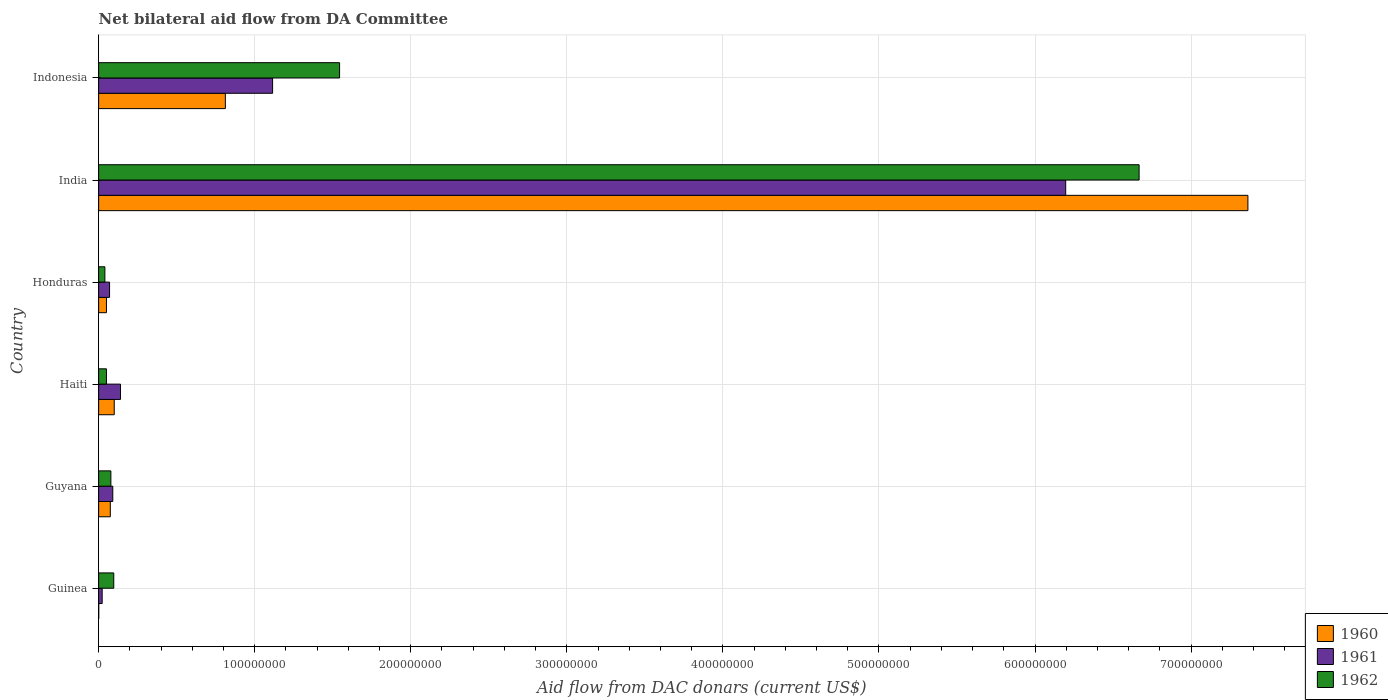How many different coloured bars are there?
Provide a short and direct response. 3. Are the number of bars on each tick of the Y-axis equal?
Your answer should be compact. Yes. How many bars are there on the 3rd tick from the bottom?
Your response must be concise. 3. What is the label of the 4th group of bars from the top?
Give a very brief answer. Haiti. Across all countries, what is the maximum aid flow in in 1962?
Provide a succinct answer. 6.67e+08. Across all countries, what is the minimum aid flow in in 1962?
Your answer should be compact. 4.00e+06. In which country was the aid flow in in 1962 maximum?
Offer a terse response. India. In which country was the aid flow in in 1961 minimum?
Ensure brevity in your answer.  Guinea. What is the total aid flow in in 1960 in the graph?
Your answer should be very brief. 8.40e+08. What is the difference between the aid flow in in 1961 in Guyana and that in Honduras?
Give a very brief answer. 2.07e+06. What is the difference between the aid flow in in 1960 in Indonesia and the aid flow in in 1962 in Guinea?
Offer a terse response. 7.15e+07. What is the average aid flow in in 1960 per country?
Provide a short and direct response. 1.40e+08. What is the difference between the aid flow in in 1960 and aid flow in in 1962 in India?
Provide a short and direct response. 6.97e+07. In how many countries, is the aid flow in in 1960 greater than 600000000 US$?
Offer a terse response. 1. What is the ratio of the aid flow in in 1962 in Honduras to that in India?
Make the answer very short. 0.01. Is the aid flow in in 1961 in Guyana less than that in Indonesia?
Your answer should be very brief. Yes. What is the difference between the highest and the second highest aid flow in in 1960?
Give a very brief answer. 6.55e+08. What is the difference between the highest and the lowest aid flow in in 1962?
Ensure brevity in your answer.  6.63e+08. Is the sum of the aid flow in in 1960 in Honduras and India greater than the maximum aid flow in in 1962 across all countries?
Offer a terse response. Yes. What does the 1st bar from the top in Haiti represents?
Provide a short and direct response. 1962. What does the 1st bar from the bottom in Honduras represents?
Provide a short and direct response. 1960. Is it the case that in every country, the sum of the aid flow in in 1960 and aid flow in in 1962 is greater than the aid flow in in 1961?
Provide a short and direct response. Yes. How many bars are there?
Keep it short and to the point. 18. Are all the bars in the graph horizontal?
Provide a short and direct response. Yes. Are the values on the major ticks of X-axis written in scientific E-notation?
Give a very brief answer. No. Does the graph contain any zero values?
Offer a very short reply. No. How many legend labels are there?
Your answer should be very brief. 3. What is the title of the graph?
Your answer should be very brief. Net bilateral aid flow from DA Committee. What is the label or title of the X-axis?
Give a very brief answer. Aid flow from DAC donars (current US$). What is the Aid flow from DAC donars (current US$) in 1960 in Guinea?
Make the answer very short. 6.00e+04. What is the Aid flow from DAC donars (current US$) in 1961 in Guinea?
Your answer should be compact. 2.27e+06. What is the Aid flow from DAC donars (current US$) in 1962 in Guinea?
Provide a succinct answer. 9.70e+06. What is the Aid flow from DAC donars (current US$) of 1960 in Guyana?
Keep it short and to the point. 7.47e+06. What is the Aid flow from DAC donars (current US$) in 1961 in Guyana?
Ensure brevity in your answer.  9.07e+06. What is the Aid flow from DAC donars (current US$) of 1962 in Guyana?
Your answer should be very brief. 7.84e+06. What is the Aid flow from DAC donars (current US$) in 1961 in Haiti?
Your answer should be very brief. 1.40e+07. What is the Aid flow from DAC donars (current US$) of 1962 in Haiti?
Offer a very short reply. 5.01e+06. What is the Aid flow from DAC donars (current US$) of 1960 in Honduras?
Offer a very short reply. 5.01e+06. What is the Aid flow from DAC donars (current US$) in 1961 in Honduras?
Offer a terse response. 7.00e+06. What is the Aid flow from DAC donars (current US$) in 1960 in India?
Ensure brevity in your answer.  7.36e+08. What is the Aid flow from DAC donars (current US$) of 1961 in India?
Your response must be concise. 6.20e+08. What is the Aid flow from DAC donars (current US$) in 1962 in India?
Your response must be concise. 6.67e+08. What is the Aid flow from DAC donars (current US$) of 1960 in Indonesia?
Your response must be concise. 8.12e+07. What is the Aid flow from DAC donars (current US$) of 1961 in Indonesia?
Your response must be concise. 1.11e+08. What is the Aid flow from DAC donars (current US$) in 1962 in Indonesia?
Offer a terse response. 1.54e+08. Across all countries, what is the maximum Aid flow from DAC donars (current US$) of 1960?
Offer a very short reply. 7.36e+08. Across all countries, what is the maximum Aid flow from DAC donars (current US$) of 1961?
Your response must be concise. 6.20e+08. Across all countries, what is the maximum Aid flow from DAC donars (current US$) of 1962?
Provide a short and direct response. 6.67e+08. Across all countries, what is the minimum Aid flow from DAC donars (current US$) in 1961?
Your answer should be very brief. 2.27e+06. Across all countries, what is the minimum Aid flow from DAC donars (current US$) in 1962?
Give a very brief answer. 4.00e+06. What is the total Aid flow from DAC donars (current US$) of 1960 in the graph?
Your answer should be compact. 8.40e+08. What is the total Aid flow from DAC donars (current US$) in 1961 in the graph?
Offer a very short reply. 7.63e+08. What is the total Aid flow from DAC donars (current US$) of 1962 in the graph?
Keep it short and to the point. 8.48e+08. What is the difference between the Aid flow from DAC donars (current US$) of 1960 in Guinea and that in Guyana?
Your response must be concise. -7.41e+06. What is the difference between the Aid flow from DAC donars (current US$) in 1961 in Guinea and that in Guyana?
Provide a succinct answer. -6.80e+06. What is the difference between the Aid flow from DAC donars (current US$) in 1962 in Guinea and that in Guyana?
Provide a short and direct response. 1.86e+06. What is the difference between the Aid flow from DAC donars (current US$) in 1960 in Guinea and that in Haiti?
Offer a very short reply. -9.94e+06. What is the difference between the Aid flow from DAC donars (current US$) in 1961 in Guinea and that in Haiti?
Your response must be concise. -1.17e+07. What is the difference between the Aid flow from DAC donars (current US$) in 1962 in Guinea and that in Haiti?
Ensure brevity in your answer.  4.69e+06. What is the difference between the Aid flow from DAC donars (current US$) in 1960 in Guinea and that in Honduras?
Provide a succinct answer. -4.95e+06. What is the difference between the Aid flow from DAC donars (current US$) of 1961 in Guinea and that in Honduras?
Keep it short and to the point. -4.73e+06. What is the difference between the Aid flow from DAC donars (current US$) in 1962 in Guinea and that in Honduras?
Make the answer very short. 5.70e+06. What is the difference between the Aid flow from DAC donars (current US$) in 1960 in Guinea and that in India?
Ensure brevity in your answer.  -7.36e+08. What is the difference between the Aid flow from DAC donars (current US$) in 1961 in Guinea and that in India?
Offer a terse response. -6.17e+08. What is the difference between the Aid flow from DAC donars (current US$) in 1962 in Guinea and that in India?
Your response must be concise. -6.57e+08. What is the difference between the Aid flow from DAC donars (current US$) in 1960 in Guinea and that in Indonesia?
Make the answer very short. -8.11e+07. What is the difference between the Aid flow from DAC donars (current US$) of 1961 in Guinea and that in Indonesia?
Make the answer very short. -1.09e+08. What is the difference between the Aid flow from DAC donars (current US$) in 1962 in Guinea and that in Indonesia?
Your response must be concise. -1.45e+08. What is the difference between the Aid flow from DAC donars (current US$) in 1960 in Guyana and that in Haiti?
Provide a succinct answer. -2.53e+06. What is the difference between the Aid flow from DAC donars (current US$) in 1961 in Guyana and that in Haiti?
Your response must be concise. -4.93e+06. What is the difference between the Aid flow from DAC donars (current US$) of 1962 in Guyana and that in Haiti?
Provide a short and direct response. 2.83e+06. What is the difference between the Aid flow from DAC donars (current US$) in 1960 in Guyana and that in Honduras?
Provide a succinct answer. 2.46e+06. What is the difference between the Aid flow from DAC donars (current US$) in 1961 in Guyana and that in Honduras?
Provide a short and direct response. 2.07e+06. What is the difference between the Aid flow from DAC donars (current US$) in 1962 in Guyana and that in Honduras?
Provide a short and direct response. 3.84e+06. What is the difference between the Aid flow from DAC donars (current US$) of 1960 in Guyana and that in India?
Your response must be concise. -7.29e+08. What is the difference between the Aid flow from DAC donars (current US$) in 1961 in Guyana and that in India?
Offer a terse response. -6.11e+08. What is the difference between the Aid flow from DAC donars (current US$) in 1962 in Guyana and that in India?
Offer a terse response. -6.59e+08. What is the difference between the Aid flow from DAC donars (current US$) in 1960 in Guyana and that in Indonesia?
Make the answer very short. -7.37e+07. What is the difference between the Aid flow from DAC donars (current US$) of 1961 in Guyana and that in Indonesia?
Ensure brevity in your answer.  -1.02e+08. What is the difference between the Aid flow from DAC donars (current US$) of 1962 in Guyana and that in Indonesia?
Offer a very short reply. -1.47e+08. What is the difference between the Aid flow from DAC donars (current US$) of 1960 in Haiti and that in Honduras?
Keep it short and to the point. 4.99e+06. What is the difference between the Aid flow from DAC donars (current US$) in 1962 in Haiti and that in Honduras?
Provide a succinct answer. 1.01e+06. What is the difference between the Aid flow from DAC donars (current US$) of 1960 in Haiti and that in India?
Offer a very short reply. -7.26e+08. What is the difference between the Aid flow from DAC donars (current US$) of 1961 in Haiti and that in India?
Your answer should be compact. -6.06e+08. What is the difference between the Aid flow from DAC donars (current US$) of 1962 in Haiti and that in India?
Provide a short and direct response. -6.62e+08. What is the difference between the Aid flow from DAC donars (current US$) in 1960 in Haiti and that in Indonesia?
Make the answer very short. -7.12e+07. What is the difference between the Aid flow from DAC donars (current US$) of 1961 in Haiti and that in Indonesia?
Give a very brief answer. -9.75e+07. What is the difference between the Aid flow from DAC donars (current US$) of 1962 in Haiti and that in Indonesia?
Make the answer very short. -1.49e+08. What is the difference between the Aid flow from DAC donars (current US$) in 1960 in Honduras and that in India?
Give a very brief answer. -7.31e+08. What is the difference between the Aid flow from DAC donars (current US$) of 1961 in Honduras and that in India?
Ensure brevity in your answer.  -6.13e+08. What is the difference between the Aid flow from DAC donars (current US$) of 1962 in Honduras and that in India?
Provide a short and direct response. -6.63e+08. What is the difference between the Aid flow from DAC donars (current US$) in 1960 in Honduras and that in Indonesia?
Make the answer very short. -7.62e+07. What is the difference between the Aid flow from DAC donars (current US$) of 1961 in Honduras and that in Indonesia?
Your response must be concise. -1.04e+08. What is the difference between the Aid flow from DAC donars (current US$) in 1962 in Honduras and that in Indonesia?
Offer a terse response. -1.50e+08. What is the difference between the Aid flow from DAC donars (current US$) of 1960 in India and that in Indonesia?
Keep it short and to the point. 6.55e+08. What is the difference between the Aid flow from DAC donars (current US$) in 1961 in India and that in Indonesia?
Keep it short and to the point. 5.08e+08. What is the difference between the Aid flow from DAC donars (current US$) of 1962 in India and that in Indonesia?
Provide a succinct answer. 5.12e+08. What is the difference between the Aid flow from DAC donars (current US$) of 1960 in Guinea and the Aid flow from DAC donars (current US$) of 1961 in Guyana?
Provide a short and direct response. -9.01e+06. What is the difference between the Aid flow from DAC donars (current US$) of 1960 in Guinea and the Aid flow from DAC donars (current US$) of 1962 in Guyana?
Your answer should be compact. -7.78e+06. What is the difference between the Aid flow from DAC donars (current US$) in 1961 in Guinea and the Aid flow from DAC donars (current US$) in 1962 in Guyana?
Make the answer very short. -5.57e+06. What is the difference between the Aid flow from DAC donars (current US$) in 1960 in Guinea and the Aid flow from DAC donars (current US$) in 1961 in Haiti?
Make the answer very short. -1.39e+07. What is the difference between the Aid flow from DAC donars (current US$) in 1960 in Guinea and the Aid flow from DAC donars (current US$) in 1962 in Haiti?
Keep it short and to the point. -4.95e+06. What is the difference between the Aid flow from DAC donars (current US$) of 1961 in Guinea and the Aid flow from DAC donars (current US$) of 1962 in Haiti?
Give a very brief answer. -2.74e+06. What is the difference between the Aid flow from DAC donars (current US$) in 1960 in Guinea and the Aid flow from DAC donars (current US$) in 1961 in Honduras?
Your response must be concise. -6.94e+06. What is the difference between the Aid flow from DAC donars (current US$) in 1960 in Guinea and the Aid flow from DAC donars (current US$) in 1962 in Honduras?
Offer a terse response. -3.94e+06. What is the difference between the Aid flow from DAC donars (current US$) in 1961 in Guinea and the Aid flow from DAC donars (current US$) in 1962 in Honduras?
Ensure brevity in your answer.  -1.73e+06. What is the difference between the Aid flow from DAC donars (current US$) of 1960 in Guinea and the Aid flow from DAC donars (current US$) of 1961 in India?
Your response must be concise. -6.20e+08. What is the difference between the Aid flow from DAC donars (current US$) in 1960 in Guinea and the Aid flow from DAC donars (current US$) in 1962 in India?
Offer a terse response. -6.67e+08. What is the difference between the Aid flow from DAC donars (current US$) of 1961 in Guinea and the Aid flow from DAC donars (current US$) of 1962 in India?
Give a very brief answer. -6.64e+08. What is the difference between the Aid flow from DAC donars (current US$) in 1960 in Guinea and the Aid flow from DAC donars (current US$) in 1961 in Indonesia?
Your response must be concise. -1.11e+08. What is the difference between the Aid flow from DAC donars (current US$) of 1960 in Guinea and the Aid flow from DAC donars (current US$) of 1962 in Indonesia?
Your answer should be very brief. -1.54e+08. What is the difference between the Aid flow from DAC donars (current US$) of 1961 in Guinea and the Aid flow from DAC donars (current US$) of 1962 in Indonesia?
Offer a terse response. -1.52e+08. What is the difference between the Aid flow from DAC donars (current US$) in 1960 in Guyana and the Aid flow from DAC donars (current US$) in 1961 in Haiti?
Give a very brief answer. -6.53e+06. What is the difference between the Aid flow from DAC donars (current US$) in 1960 in Guyana and the Aid flow from DAC donars (current US$) in 1962 in Haiti?
Give a very brief answer. 2.46e+06. What is the difference between the Aid flow from DAC donars (current US$) of 1961 in Guyana and the Aid flow from DAC donars (current US$) of 1962 in Haiti?
Keep it short and to the point. 4.06e+06. What is the difference between the Aid flow from DAC donars (current US$) of 1960 in Guyana and the Aid flow from DAC donars (current US$) of 1962 in Honduras?
Keep it short and to the point. 3.47e+06. What is the difference between the Aid flow from DAC donars (current US$) of 1961 in Guyana and the Aid flow from DAC donars (current US$) of 1962 in Honduras?
Your answer should be compact. 5.07e+06. What is the difference between the Aid flow from DAC donars (current US$) of 1960 in Guyana and the Aid flow from DAC donars (current US$) of 1961 in India?
Your response must be concise. -6.12e+08. What is the difference between the Aid flow from DAC donars (current US$) in 1960 in Guyana and the Aid flow from DAC donars (current US$) in 1962 in India?
Offer a terse response. -6.59e+08. What is the difference between the Aid flow from DAC donars (current US$) in 1961 in Guyana and the Aid flow from DAC donars (current US$) in 1962 in India?
Provide a short and direct response. -6.58e+08. What is the difference between the Aid flow from DAC donars (current US$) in 1960 in Guyana and the Aid flow from DAC donars (current US$) in 1961 in Indonesia?
Make the answer very short. -1.04e+08. What is the difference between the Aid flow from DAC donars (current US$) of 1960 in Guyana and the Aid flow from DAC donars (current US$) of 1962 in Indonesia?
Your answer should be very brief. -1.47e+08. What is the difference between the Aid flow from DAC donars (current US$) of 1961 in Guyana and the Aid flow from DAC donars (current US$) of 1962 in Indonesia?
Your response must be concise. -1.45e+08. What is the difference between the Aid flow from DAC donars (current US$) in 1960 in Haiti and the Aid flow from DAC donars (current US$) in 1961 in Honduras?
Keep it short and to the point. 3.00e+06. What is the difference between the Aid flow from DAC donars (current US$) in 1960 in Haiti and the Aid flow from DAC donars (current US$) in 1962 in Honduras?
Give a very brief answer. 6.00e+06. What is the difference between the Aid flow from DAC donars (current US$) of 1960 in Haiti and the Aid flow from DAC donars (current US$) of 1961 in India?
Your answer should be very brief. -6.10e+08. What is the difference between the Aid flow from DAC donars (current US$) of 1960 in Haiti and the Aid flow from DAC donars (current US$) of 1962 in India?
Give a very brief answer. -6.57e+08. What is the difference between the Aid flow from DAC donars (current US$) of 1961 in Haiti and the Aid flow from DAC donars (current US$) of 1962 in India?
Your response must be concise. -6.53e+08. What is the difference between the Aid flow from DAC donars (current US$) in 1960 in Haiti and the Aid flow from DAC donars (current US$) in 1961 in Indonesia?
Your answer should be very brief. -1.01e+08. What is the difference between the Aid flow from DAC donars (current US$) of 1960 in Haiti and the Aid flow from DAC donars (current US$) of 1962 in Indonesia?
Ensure brevity in your answer.  -1.44e+08. What is the difference between the Aid flow from DAC donars (current US$) of 1961 in Haiti and the Aid flow from DAC donars (current US$) of 1962 in Indonesia?
Keep it short and to the point. -1.40e+08. What is the difference between the Aid flow from DAC donars (current US$) in 1960 in Honduras and the Aid flow from DAC donars (current US$) in 1961 in India?
Keep it short and to the point. -6.15e+08. What is the difference between the Aid flow from DAC donars (current US$) in 1960 in Honduras and the Aid flow from DAC donars (current US$) in 1962 in India?
Provide a succinct answer. -6.62e+08. What is the difference between the Aid flow from DAC donars (current US$) in 1961 in Honduras and the Aid flow from DAC donars (current US$) in 1962 in India?
Make the answer very short. -6.60e+08. What is the difference between the Aid flow from DAC donars (current US$) of 1960 in Honduras and the Aid flow from DAC donars (current US$) of 1961 in Indonesia?
Make the answer very short. -1.06e+08. What is the difference between the Aid flow from DAC donars (current US$) in 1960 in Honduras and the Aid flow from DAC donars (current US$) in 1962 in Indonesia?
Keep it short and to the point. -1.49e+08. What is the difference between the Aid flow from DAC donars (current US$) in 1961 in Honduras and the Aid flow from DAC donars (current US$) in 1962 in Indonesia?
Your answer should be very brief. -1.47e+08. What is the difference between the Aid flow from DAC donars (current US$) of 1960 in India and the Aid flow from DAC donars (current US$) of 1961 in Indonesia?
Provide a short and direct response. 6.25e+08. What is the difference between the Aid flow from DAC donars (current US$) in 1960 in India and the Aid flow from DAC donars (current US$) in 1962 in Indonesia?
Your answer should be compact. 5.82e+08. What is the difference between the Aid flow from DAC donars (current US$) in 1961 in India and the Aid flow from DAC donars (current US$) in 1962 in Indonesia?
Give a very brief answer. 4.65e+08. What is the average Aid flow from DAC donars (current US$) in 1960 per country?
Your answer should be very brief. 1.40e+08. What is the average Aid flow from DAC donars (current US$) of 1961 per country?
Make the answer very short. 1.27e+08. What is the average Aid flow from DAC donars (current US$) in 1962 per country?
Ensure brevity in your answer.  1.41e+08. What is the difference between the Aid flow from DAC donars (current US$) in 1960 and Aid flow from DAC donars (current US$) in 1961 in Guinea?
Ensure brevity in your answer.  -2.21e+06. What is the difference between the Aid flow from DAC donars (current US$) in 1960 and Aid flow from DAC donars (current US$) in 1962 in Guinea?
Provide a short and direct response. -9.64e+06. What is the difference between the Aid flow from DAC donars (current US$) of 1961 and Aid flow from DAC donars (current US$) of 1962 in Guinea?
Your answer should be compact. -7.43e+06. What is the difference between the Aid flow from DAC donars (current US$) in 1960 and Aid flow from DAC donars (current US$) in 1961 in Guyana?
Your response must be concise. -1.60e+06. What is the difference between the Aid flow from DAC donars (current US$) in 1960 and Aid flow from DAC donars (current US$) in 1962 in Guyana?
Provide a succinct answer. -3.70e+05. What is the difference between the Aid flow from DAC donars (current US$) in 1961 and Aid flow from DAC donars (current US$) in 1962 in Guyana?
Make the answer very short. 1.23e+06. What is the difference between the Aid flow from DAC donars (current US$) in 1960 and Aid flow from DAC donars (current US$) in 1961 in Haiti?
Ensure brevity in your answer.  -4.00e+06. What is the difference between the Aid flow from DAC donars (current US$) in 1960 and Aid flow from DAC donars (current US$) in 1962 in Haiti?
Your answer should be very brief. 4.99e+06. What is the difference between the Aid flow from DAC donars (current US$) of 1961 and Aid flow from DAC donars (current US$) of 1962 in Haiti?
Provide a succinct answer. 8.99e+06. What is the difference between the Aid flow from DAC donars (current US$) of 1960 and Aid flow from DAC donars (current US$) of 1961 in Honduras?
Offer a very short reply. -1.99e+06. What is the difference between the Aid flow from DAC donars (current US$) in 1960 and Aid flow from DAC donars (current US$) in 1962 in Honduras?
Provide a succinct answer. 1.01e+06. What is the difference between the Aid flow from DAC donars (current US$) in 1961 and Aid flow from DAC donars (current US$) in 1962 in Honduras?
Give a very brief answer. 3.00e+06. What is the difference between the Aid flow from DAC donars (current US$) of 1960 and Aid flow from DAC donars (current US$) of 1961 in India?
Your answer should be very brief. 1.17e+08. What is the difference between the Aid flow from DAC donars (current US$) in 1960 and Aid flow from DAC donars (current US$) in 1962 in India?
Offer a very short reply. 6.97e+07. What is the difference between the Aid flow from DAC donars (current US$) in 1961 and Aid flow from DAC donars (current US$) in 1962 in India?
Your answer should be compact. -4.70e+07. What is the difference between the Aid flow from DAC donars (current US$) in 1960 and Aid flow from DAC donars (current US$) in 1961 in Indonesia?
Keep it short and to the point. -3.03e+07. What is the difference between the Aid flow from DAC donars (current US$) of 1960 and Aid flow from DAC donars (current US$) of 1962 in Indonesia?
Offer a terse response. -7.32e+07. What is the difference between the Aid flow from DAC donars (current US$) of 1961 and Aid flow from DAC donars (current US$) of 1962 in Indonesia?
Make the answer very short. -4.29e+07. What is the ratio of the Aid flow from DAC donars (current US$) of 1960 in Guinea to that in Guyana?
Offer a terse response. 0.01. What is the ratio of the Aid flow from DAC donars (current US$) of 1961 in Guinea to that in Guyana?
Give a very brief answer. 0.25. What is the ratio of the Aid flow from DAC donars (current US$) in 1962 in Guinea to that in Guyana?
Your answer should be compact. 1.24. What is the ratio of the Aid flow from DAC donars (current US$) of 1960 in Guinea to that in Haiti?
Make the answer very short. 0.01. What is the ratio of the Aid flow from DAC donars (current US$) of 1961 in Guinea to that in Haiti?
Your answer should be compact. 0.16. What is the ratio of the Aid flow from DAC donars (current US$) in 1962 in Guinea to that in Haiti?
Give a very brief answer. 1.94. What is the ratio of the Aid flow from DAC donars (current US$) of 1960 in Guinea to that in Honduras?
Provide a short and direct response. 0.01. What is the ratio of the Aid flow from DAC donars (current US$) of 1961 in Guinea to that in Honduras?
Keep it short and to the point. 0.32. What is the ratio of the Aid flow from DAC donars (current US$) of 1962 in Guinea to that in Honduras?
Your answer should be very brief. 2.42. What is the ratio of the Aid flow from DAC donars (current US$) in 1960 in Guinea to that in India?
Keep it short and to the point. 0. What is the ratio of the Aid flow from DAC donars (current US$) in 1961 in Guinea to that in India?
Your answer should be compact. 0. What is the ratio of the Aid flow from DAC donars (current US$) of 1962 in Guinea to that in India?
Give a very brief answer. 0.01. What is the ratio of the Aid flow from DAC donars (current US$) of 1960 in Guinea to that in Indonesia?
Offer a terse response. 0. What is the ratio of the Aid flow from DAC donars (current US$) of 1961 in Guinea to that in Indonesia?
Make the answer very short. 0.02. What is the ratio of the Aid flow from DAC donars (current US$) in 1962 in Guinea to that in Indonesia?
Make the answer very short. 0.06. What is the ratio of the Aid flow from DAC donars (current US$) in 1960 in Guyana to that in Haiti?
Offer a very short reply. 0.75. What is the ratio of the Aid flow from DAC donars (current US$) in 1961 in Guyana to that in Haiti?
Your response must be concise. 0.65. What is the ratio of the Aid flow from DAC donars (current US$) of 1962 in Guyana to that in Haiti?
Your answer should be very brief. 1.56. What is the ratio of the Aid flow from DAC donars (current US$) of 1960 in Guyana to that in Honduras?
Your answer should be compact. 1.49. What is the ratio of the Aid flow from DAC donars (current US$) in 1961 in Guyana to that in Honduras?
Your answer should be compact. 1.3. What is the ratio of the Aid flow from DAC donars (current US$) in 1962 in Guyana to that in Honduras?
Offer a very short reply. 1.96. What is the ratio of the Aid flow from DAC donars (current US$) of 1960 in Guyana to that in India?
Keep it short and to the point. 0.01. What is the ratio of the Aid flow from DAC donars (current US$) in 1961 in Guyana to that in India?
Provide a succinct answer. 0.01. What is the ratio of the Aid flow from DAC donars (current US$) of 1962 in Guyana to that in India?
Give a very brief answer. 0.01. What is the ratio of the Aid flow from DAC donars (current US$) in 1960 in Guyana to that in Indonesia?
Offer a terse response. 0.09. What is the ratio of the Aid flow from DAC donars (current US$) in 1961 in Guyana to that in Indonesia?
Keep it short and to the point. 0.08. What is the ratio of the Aid flow from DAC donars (current US$) of 1962 in Guyana to that in Indonesia?
Make the answer very short. 0.05. What is the ratio of the Aid flow from DAC donars (current US$) in 1960 in Haiti to that in Honduras?
Your answer should be very brief. 2. What is the ratio of the Aid flow from DAC donars (current US$) of 1962 in Haiti to that in Honduras?
Your answer should be compact. 1.25. What is the ratio of the Aid flow from DAC donars (current US$) in 1960 in Haiti to that in India?
Your answer should be compact. 0.01. What is the ratio of the Aid flow from DAC donars (current US$) in 1961 in Haiti to that in India?
Ensure brevity in your answer.  0.02. What is the ratio of the Aid flow from DAC donars (current US$) of 1962 in Haiti to that in India?
Offer a very short reply. 0.01. What is the ratio of the Aid flow from DAC donars (current US$) in 1960 in Haiti to that in Indonesia?
Ensure brevity in your answer.  0.12. What is the ratio of the Aid flow from DAC donars (current US$) of 1961 in Haiti to that in Indonesia?
Offer a very short reply. 0.13. What is the ratio of the Aid flow from DAC donars (current US$) of 1962 in Haiti to that in Indonesia?
Your response must be concise. 0.03. What is the ratio of the Aid flow from DAC donars (current US$) in 1960 in Honduras to that in India?
Make the answer very short. 0.01. What is the ratio of the Aid flow from DAC donars (current US$) of 1961 in Honduras to that in India?
Give a very brief answer. 0.01. What is the ratio of the Aid flow from DAC donars (current US$) of 1962 in Honduras to that in India?
Your response must be concise. 0.01. What is the ratio of the Aid flow from DAC donars (current US$) in 1960 in Honduras to that in Indonesia?
Offer a very short reply. 0.06. What is the ratio of the Aid flow from DAC donars (current US$) in 1961 in Honduras to that in Indonesia?
Your answer should be compact. 0.06. What is the ratio of the Aid flow from DAC donars (current US$) of 1962 in Honduras to that in Indonesia?
Offer a very short reply. 0.03. What is the ratio of the Aid flow from DAC donars (current US$) in 1960 in India to that in Indonesia?
Give a very brief answer. 9.07. What is the ratio of the Aid flow from DAC donars (current US$) of 1961 in India to that in Indonesia?
Provide a short and direct response. 5.56. What is the ratio of the Aid flow from DAC donars (current US$) of 1962 in India to that in Indonesia?
Your answer should be very brief. 4.32. What is the difference between the highest and the second highest Aid flow from DAC donars (current US$) of 1960?
Make the answer very short. 6.55e+08. What is the difference between the highest and the second highest Aid flow from DAC donars (current US$) of 1961?
Provide a short and direct response. 5.08e+08. What is the difference between the highest and the second highest Aid flow from DAC donars (current US$) in 1962?
Your answer should be very brief. 5.12e+08. What is the difference between the highest and the lowest Aid flow from DAC donars (current US$) in 1960?
Make the answer very short. 7.36e+08. What is the difference between the highest and the lowest Aid flow from DAC donars (current US$) in 1961?
Provide a succinct answer. 6.17e+08. What is the difference between the highest and the lowest Aid flow from DAC donars (current US$) in 1962?
Make the answer very short. 6.63e+08. 